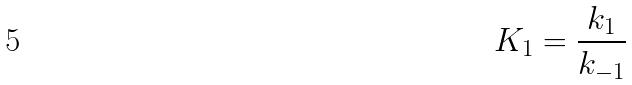Convert formula to latex. <formula><loc_0><loc_0><loc_500><loc_500>K _ { 1 } = \frac { k _ { 1 } } { k _ { - 1 } }</formula> 